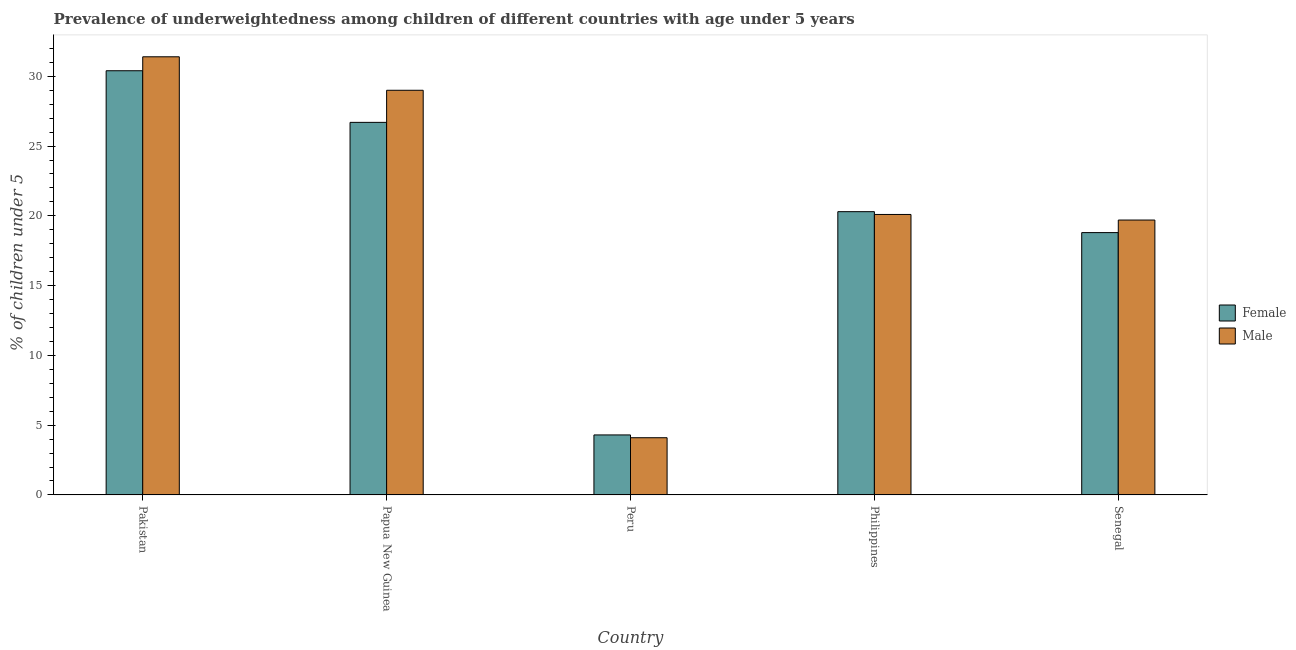How many groups of bars are there?
Offer a very short reply. 5. Are the number of bars per tick equal to the number of legend labels?
Keep it short and to the point. Yes. What is the label of the 4th group of bars from the left?
Offer a very short reply. Philippines. What is the percentage of underweighted male children in Pakistan?
Make the answer very short. 31.4. Across all countries, what is the maximum percentage of underweighted female children?
Offer a very short reply. 30.4. Across all countries, what is the minimum percentage of underweighted female children?
Give a very brief answer. 4.3. In which country was the percentage of underweighted female children maximum?
Offer a terse response. Pakistan. What is the total percentage of underweighted male children in the graph?
Offer a terse response. 104.3. What is the difference between the percentage of underweighted male children in Peru and that in Philippines?
Make the answer very short. -16. What is the difference between the percentage of underweighted female children in Senegal and the percentage of underweighted male children in Pakistan?
Your answer should be compact. -12.6. What is the average percentage of underweighted male children per country?
Offer a very short reply. 20.86. What is the difference between the percentage of underweighted male children and percentage of underweighted female children in Senegal?
Provide a short and direct response. 0.9. What is the ratio of the percentage of underweighted male children in Papua New Guinea to that in Senegal?
Keep it short and to the point. 1.47. Is the percentage of underweighted female children in Philippines less than that in Senegal?
Provide a short and direct response. No. Is the difference between the percentage of underweighted female children in Philippines and Senegal greater than the difference between the percentage of underweighted male children in Philippines and Senegal?
Keep it short and to the point. Yes. What is the difference between the highest and the second highest percentage of underweighted female children?
Make the answer very short. 3.7. What is the difference between the highest and the lowest percentage of underweighted male children?
Offer a very short reply. 27.3. In how many countries, is the percentage of underweighted male children greater than the average percentage of underweighted male children taken over all countries?
Offer a very short reply. 2. What does the 1st bar from the right in Peru represents?
Give a very brief answer. Male. How many bars are there?
Keep it short and to the point. 10. Are all the bars in the graph horizontal?
Your answer should be very brief. No. What is the difference between two consecutive major ticks on the Y-axis?
Keep it short and to the point. 5. Are the values on the major ticks of Y-axis written in scientific E-notation?
Your answer should be very brief. No. Does the graph contain any zero values?
Give a very brief answer. No. Does the graph contain grids?
Give a very brief answer. No. Where does the legend appear in the graph?
Offer a terse response. Center right. How many legend labels are there?
Keep it short and to the point. 2. How are the legend labels stacked?
Your response must be concise. Vertical. What is the title of the graph?
Offer a terse response. Prevalence of underweightedness among children of different countries with age under 5 years. Does "Forest" appear as one of the legend labels in the graph?
Provide a short and direct response. No. What is the label or title of the X-axis?
Provide a short and direct response. Country. What is the label or title of the Y-axis?
Give a very brief answer.  % of children under 5. What is the  % of children under 5 in Female in Pakistan?
Offer a very short reply. 30.4. What is the  % of children under 5 in Male in Pakistan?
Ensure brevity in your answer.  31.4. What is the  % of children under 5 in Female in Papua New Guinea?
Keep it short and to the point. 26.7. What is the  % of children under 5 in Female in Peru?
Give a very brief answer. 4.3. What is the  % of children under 5 of Male in Peru?
Provide a succinct answer. 4.1. What is the  % of children under 5 in Female in Philippines?
Your answer should be very brief. 20.3. What is the  % of children under 5 of Male in Philippines?
Offer a terse response. 20.1. What is the  % of children under 5 of Female in Senegal?
Your answer should be compact. 18.8. What is the  % of children under 5 in Male in Senegal?
Offer a very short reply. 19.7. Across all countries, what is the maximum  % of children under 5 in Female?
Ensure brevity in your answer.  30.4. Across all countries, what is the maximum  % of children under 5 in Male?
Ensure brevity in your answer.  31.4. Across all countries, what is the minimum  % of children under 5 in Female?
Provide a short and direct response. 4.3. Across all countries, what is the minimum  % of children under 5 of Male?
Your answer should be compact. 4.1. What is the total  % of children under 5 of Female in the graph?
Your answer should be very brief. 100.5. What is the total  % of children under 5 of Male in the graph?
Make the answer very short. 104.3. What is the difference between the  % of children under 5 of Female in Pakistan and that in Papua New Guinea?
Provide a succinct answer. 3.7. What is the difference between the  % of children under 5 in Female in Pakistan and that in Peru?
Provide a short and direct response. 26.1. What is the difference between the  % of children under 5 in Male in Pakistan and that in Peru?
Make the answer very short. 27.3. What is the difference between the  % of children under 5 of Female in Pakistan and that in Senegal?
Your response must be concise. 11.6. What is the difference between the  % of children under 5 in Female in Papua New Guinea and that in Peru?
Ensure brevity in your answer.  22.4. What is the difference between the  % of children under 5 in Male in Papua New Guinea and that in Peru?
Your response must be concise. 24.9. What is the difference between the  % of children under 5 of Female in Papua New Guinea and that in Senegal?
Keep it short and to the point. 7.9. What is the difference between the  % of children under 5 of Male in Papua New Guinea and that in Senegal?
Offer a very short reply. 9.3. What is the difference between the  % of children under 5 of Female in Peru and that in Philippines?
Offer a very short reply. -16. What is the difference between the  % of children under 5 in Male in Peru and that in Philippines?
Ensure brevity in your answer.  -16. What is the difference between the  % of children under 5 in Female in Peru and that in Senegal?
Your response must be concise. -14.5. What is the difference between the  % of children under 5 of Male in Peru and that in Senegal?
Provide a short and direct response. -15.6. What is the difference between the  % of children under 5 in Male in Philippines and that in Senegal?
Provide a succinct answer. 0.4. What is the difference between the  % of children under 5 of Female in Pakistan and the  % of children under 5 of Male in Peru?
Make the answer very short. 26.3. What is the difference between the  % of children under 5 in Female in Pakistan and the  % of children under 5 in Male in Senegal?
Provide a short and direct response. 10.7. What is the difference between the  % of children under 5 in Female in Papua New Guinea and the  % of children under 5 in Male in Peru?
Offer a very short reply. 22.6. What is the difference between the  % of children under 5 of Female in Peru and the  % of children under 5 of Male in Philippines?
Provide a short and direct response. -15.8. What is the difference between the  % of children under 5 of Female in Peru and the  % of children under 5 of Male in Senegal?
Offer a very short reply. -15.4. What is the difference between the  % of children under 5 in Female in Philippines and the  % of children under 5 in Male in Senegal?
Provide a short and direct response. 0.6. What is the average  % of children under 5 of Female per country?
Ensure brevity in your answer.  20.1. What is the average  % of children under 5 in Male per country?
Provide a short and direct response. 20.86. What is the difference between the  % of children under 5 of Female and  % of children under 5 of Male in Pakistan?
Make the answer very short. -1. What is the difference between the  % of children under 5 in Female and  % of children under 5 in Male in Peru?
Your response must be concise. 0.2. What is the difference between the  % of children under 5 of Female and  % of children under 5 of Male in Philippines?
Offer a terse response. 0.2. What is the difference between the  % of children under 5 in Female and  % of children under 5 in Male in Senegal?
Your response must be concise. -0.9. What is the ratio of the  % of children under 5 of Female in Pakistan to that in Papua New Guinea?
Make the answer very short. 1.14. What is the ratio of the  % of children under 5 of Male in Pakistan to that in Papua New Guinea?
Provide a succinct answer. 1.08. What is the ratio of the  % of children under 5 in Female in Pakistan to that in Peru?
Your answer should be very brief. 7.07. What is the ratio of the  % of children under 5 in Male in Pakistan to that in Peru?
Provide a succinct answer. 7.66. What is the ratio of the  % of children under 5 in Female in Pakistan to that in Philippines?
Your answer should be compact. 1.5. What is the ratio of the  % of children under 5 of Male in Pakistan to that in Philippines?
Offer a terse response. 1.56. What is the ratio of the  % of children under 5 in Female in Pakistan to that in Senegal?
Make the answer very short. 1.62. What is the ratio of the  % of children under 5 of Male in Pakistan to that in Senegal?
Offer a terse response. 1.59. What is the ratio of the  % of children under 5 in Female in Papua New Guinea to that in Peru?
Ensure brevity in your answer.  6.21. What is the ratio of the  % of children under 5 of Male in Papua New Guinea to that in Peru?
Provide a short and direct response. 7.07. What is the ratio of the  % of children under 5 of Female in Papua New Guinea to that in Philippines?
Provide a succinct answer. 1.32. What is the ratio of the  % of children under 5 of Male in Papua New Guinea to that in Philippines?
Offer a very short reply. 1.44. What is the ratio of the  % of children under 5 in Female in Papua New Guinea to that in Senegal?
Ensure brevity in your answer.  1.42. What is the ratio of the  % of children under 5 of Male in Papua New Guinea to that in Senegal?
Offer a terse response. 1.47. What is the ratio of the  % of children under 5 of Female in Peru to that in Philippines?
Make the answer very short. 0.21. What is the ratio of the  % of children under 5 in Male in Peru to that in Philippines?
Your answer should be very brief. 0.2. What is the ratio of the  % of children under 5 in Female in Peru to that in Senegal?
Keep it short and to the point. 0.23. What is the ratio of the  % of children under 5 in Male in Peru to that in Senegal?
Your answer should be very brief. 0.21. What is the ratio of the  % of children under 5 in Female in Philippines to that in Senegal?
Your response must be concise. 1.08. What is the ratio of the  % of children under 5 of Male in Philippines to that in Senegal?
Your answer should be compact. 1.02. What is the difference between the highest and the lowest  % of children under 5 in Female?
Your response must be concise. 26.1. What is the difference between the highest and the lowest  % of children under 5 in Male?
Ensure brevity in your answer.  27.3. 